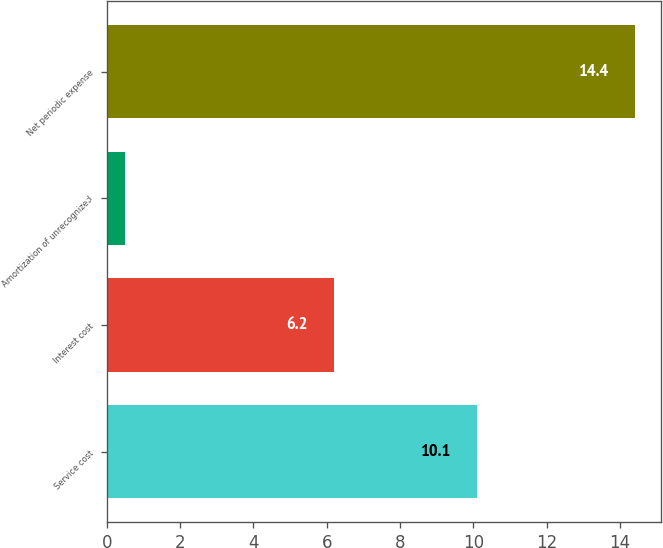<chart> <loc_0><loc_0><loc_500><loc_500><bar_chart><fcel>Service cost<fcel>Interest cost<fcel>Amortization of unrecognized<fcel>Net periodic expense<nl><fcel>10.1<fcel>6.2<fcel>0.5<fcel>14.4<nl></chart> 